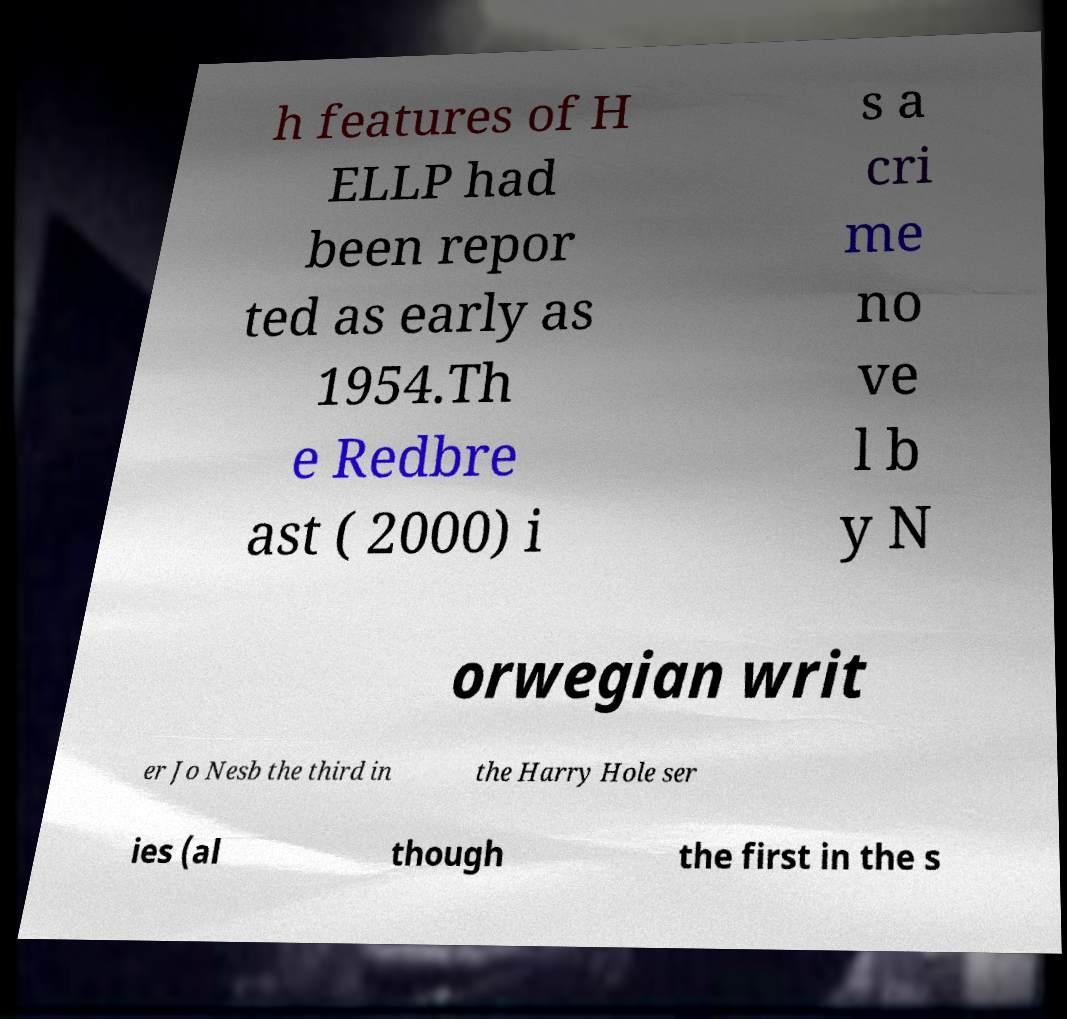For documentation purposes, I need the text within this image transcribed. Could you provide that? h features of H ELLP had been repor ted as early as 1954.Th e Redbre ast ( 2000) i s a cri me no ve l b y N orwegian writ er Jo Nesb the third in the Harry Hole ser ies (al though the first in the s 